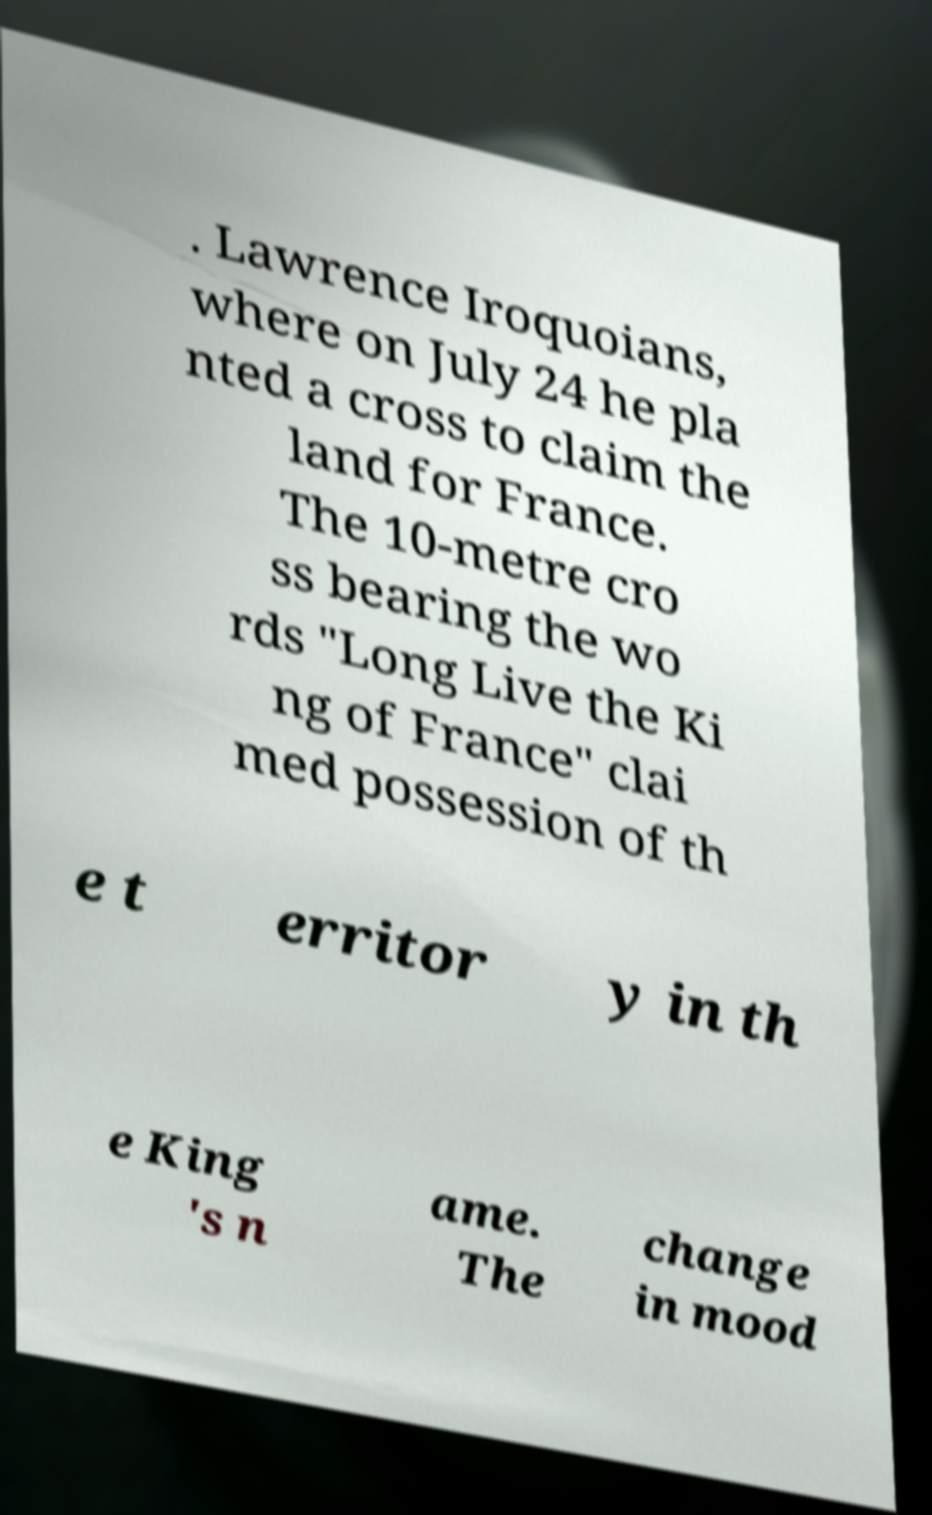Could you extract and type out the text from this image? . Lawrence Iroquoians, where on July 24 he pla nted a cross to claim the land for France. The 10-metre cro ss bearing the wo rds "Long Live the Ki ng of France" clai med possession of th e t erritor y in th e King 's n ame. The change in mood 